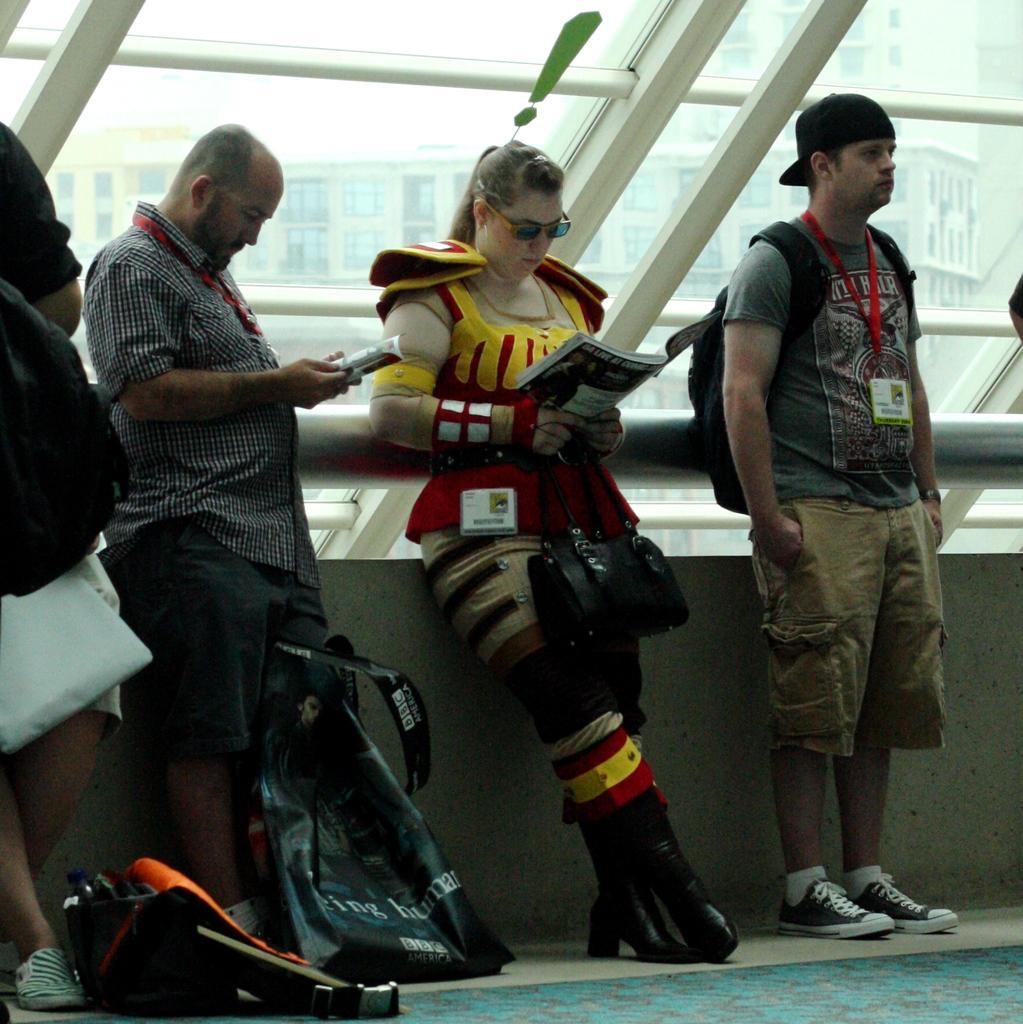How would you summarize this image in a sentence or two? In the image we can see people standing, they are wearing clothes, shoes and some of them are wearing identity card, cap and goggles. This is a book, a floor and a glass window. Out of the window we can see a building and a white sky. 